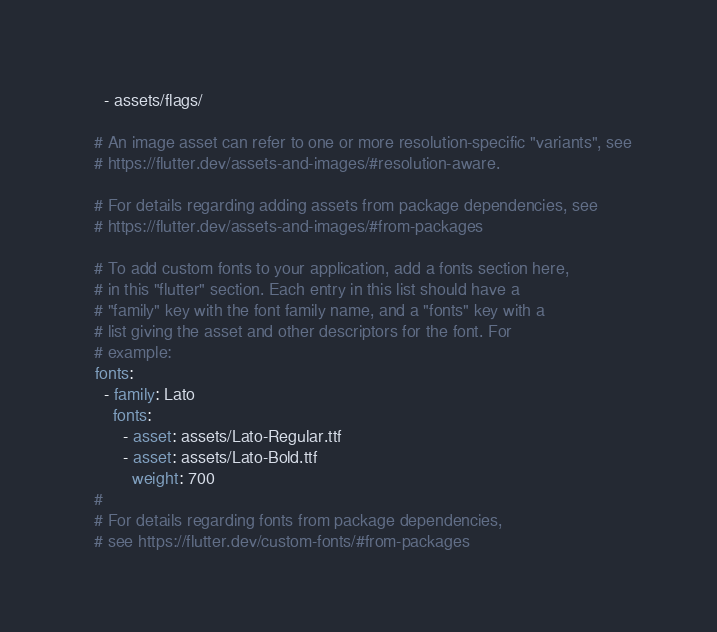<code> <loc_0><loc_0><loc_500><loc_500><_YAML_>    - assets/flags/

  # An image asset can refer to one or more resolution-specific "variants", see
  # https://flutter.dev/assets-and-images/#resolution-aware.

  # For details regarding adding assets from package dependencies, see
  # https://flutter.dev/assets-and-images/#from-packages

  # To add custom fonts to your application, add a fonts section here,
  # in this "flutter" section. Each entry in this list should have a
  # "family" key with the font family name, and a "fonts" key with a
  # list giving the asset and other descriptors for the font. For
  # example:
  fonts:
    - family: Lato
      fonts:
        - asset: assets/Lato-Regular.ttf
        - asset: assets/Lato-Bold.ttf
          weight: 700
  #
  # For details regarding fonts from package dependencies,
  # see https://flutter.dev/custom-fonts/#from-packages
</code> 